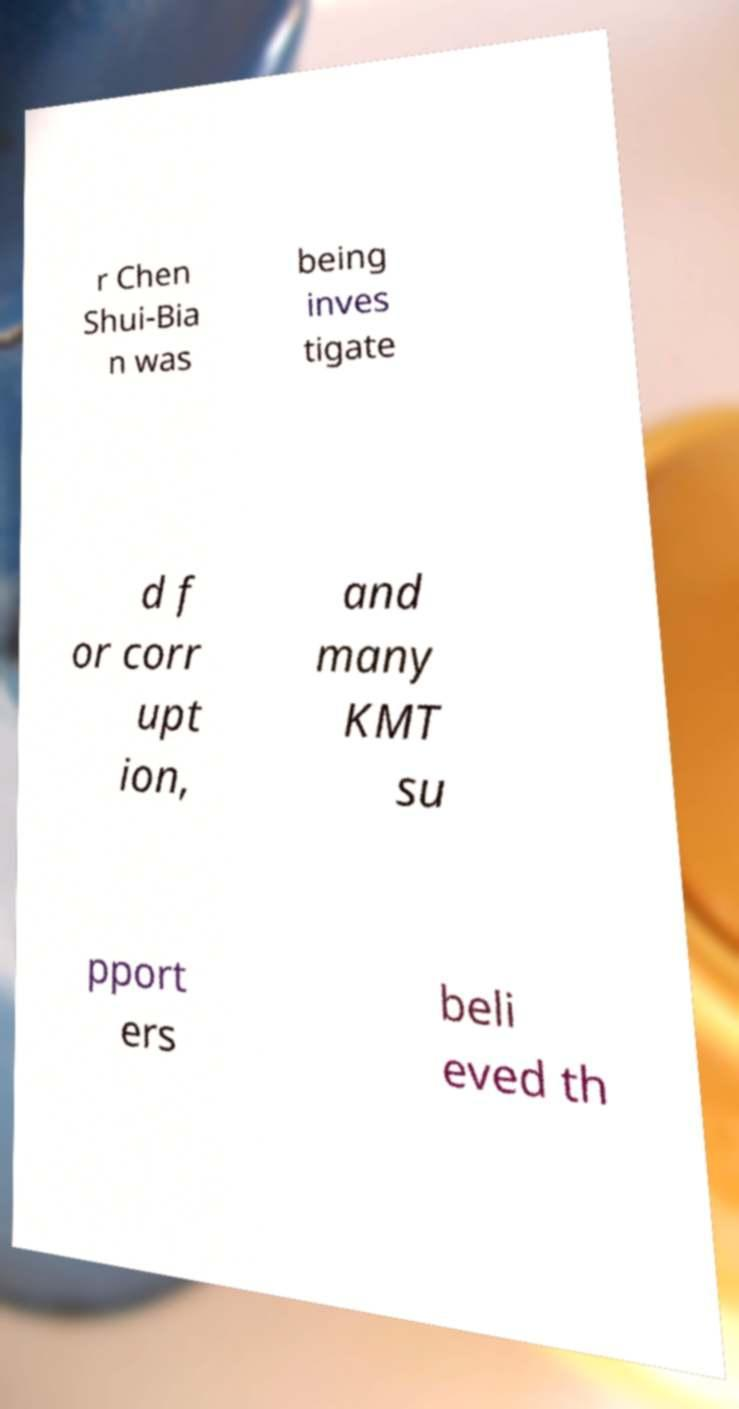There's text embedded in this image that I need extracted. Can you transcribe it verbatim? r Chen Shui-Bia n was being inves tigate d f or corr upt ion, and many KMT su pport ers beli eved th 